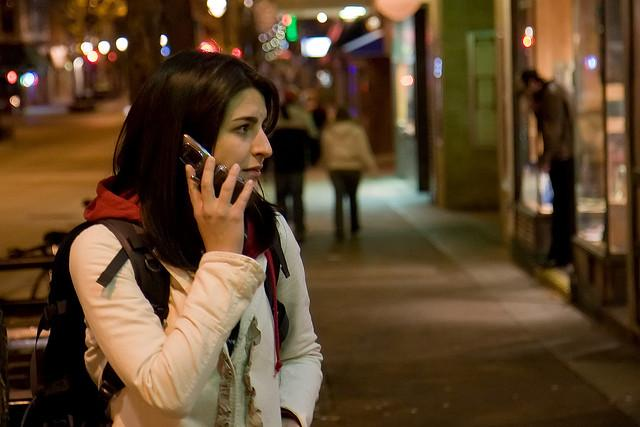What type of city district is this?

Choices:
A) government
B) warehouse
C) commercial
D) residential commercial 